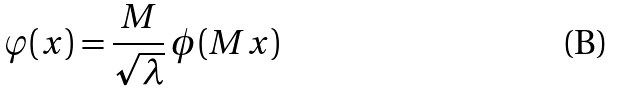Convert formula to latex. <formula><loc_0><loc_0><loc_500><loc_500>\varphi ( x ) = \frac { M } { \sqrt { \lambda } } \, \phi ( M x )</formula> 